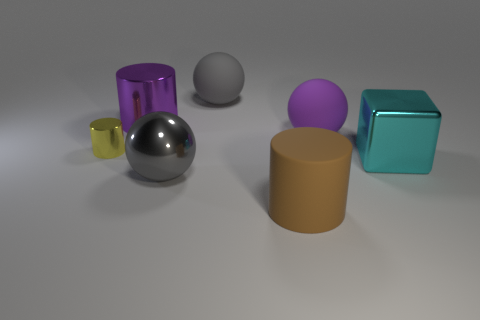Subtract all gray spheres. How many spheres are left? 1 Add 2 small yellow metal things. How many objects exist? 9 Subtract all spheres. How many objects are left? 4 Subtract 1 blocks. How many blocks are left? 0 Subtract all gray balls. How many balls are left? 1 Subtract all yellow things. Subtract all large purple spheres. How many objects are left? 5 Add 2 big gray objects. How many big gray objects are left? 4 Add 5 purple objects. How many purple objects exist? 7 Subtract 0 gray blocks. How many objects are left? 7 Subtract all brown cubes. Subtract all brown cylinders. How many cubes are left? 1 